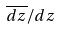Convert formula to latex. <formula><loc_0><loc_0><loc_500><loc_500>\overline { d z } / d z</formula> 